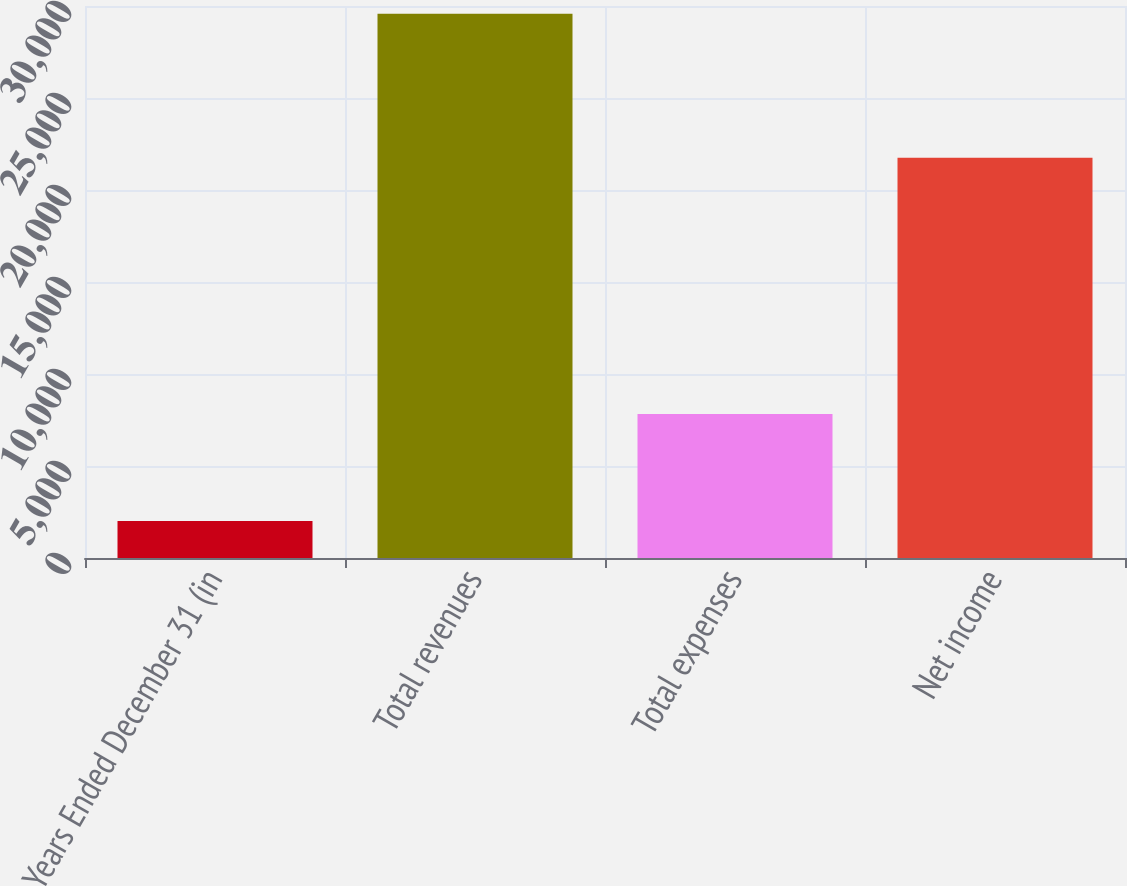Convert chart. <chart><loc_0><loc_0><loc_500><loc_500><bar_chart><fcel>Years Ended December 31 (in<fcel>Total revenues<fcel>Total expenses<fcel>Net income<nl><fcel>2014<fcel>29579<fcel>7828<fcel>21751<nl></chart> 